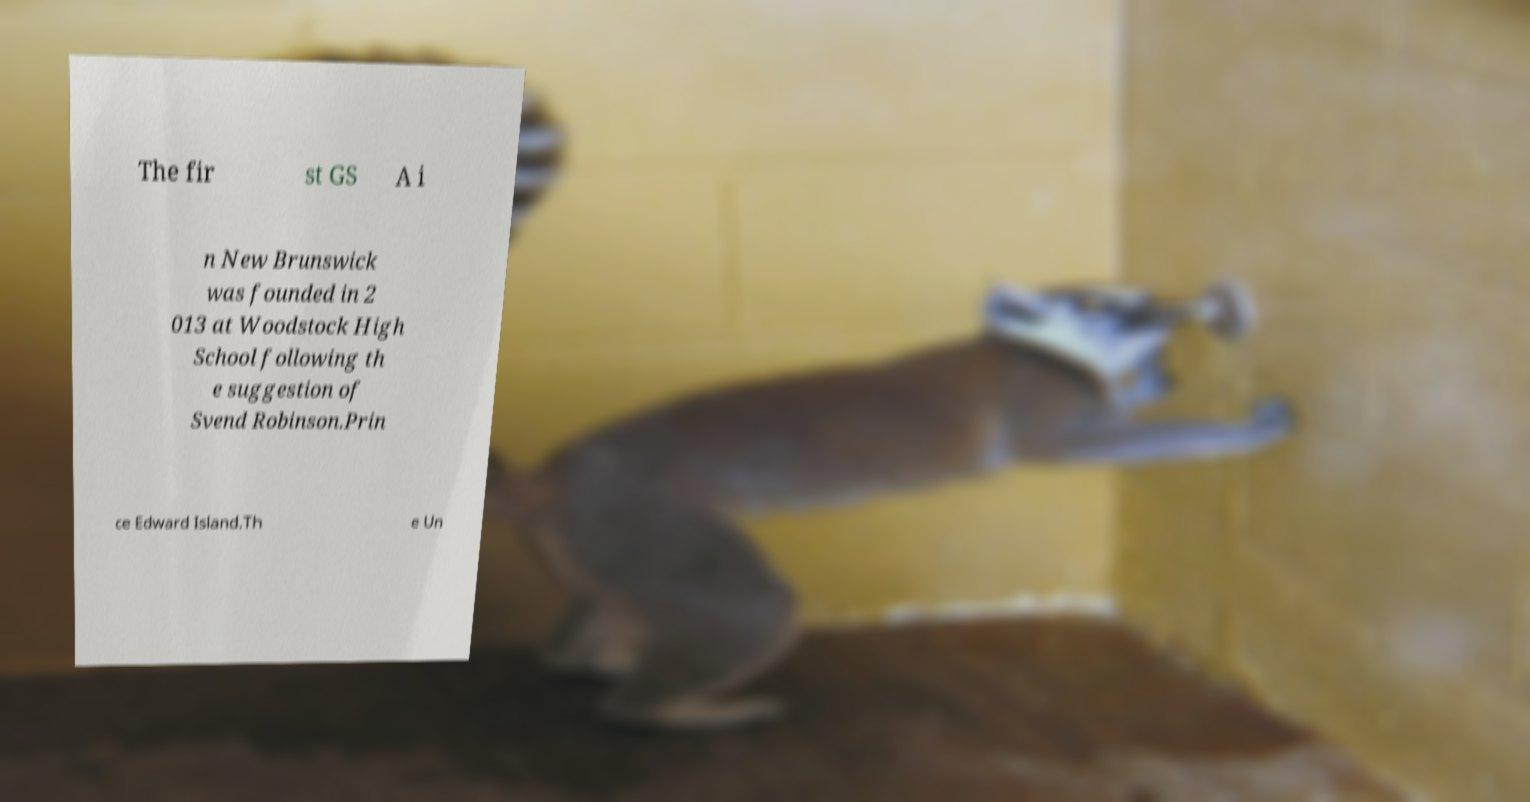There's text embedded in this image that I need extracted. Can you transcribe it verbatim? The fir st GS A i n New Brunswick was founded in 2 013 at Woodstock High School following th e suggestion of Svend Robinson.Prin ce Edward Island.Th e Un 